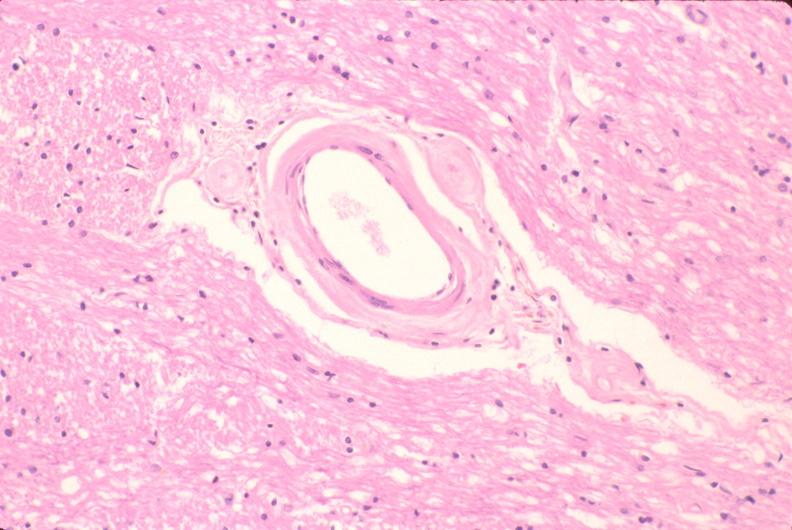what does this image show?
Answer the question using a single word or phrase. Brain 